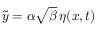Convert formula to latex. <formula><loc_0><loc_0><loc_500><loc_500>\tilde { y } = \alpha \sqrt { \beta } \, \eta ( x , t )</formula> 